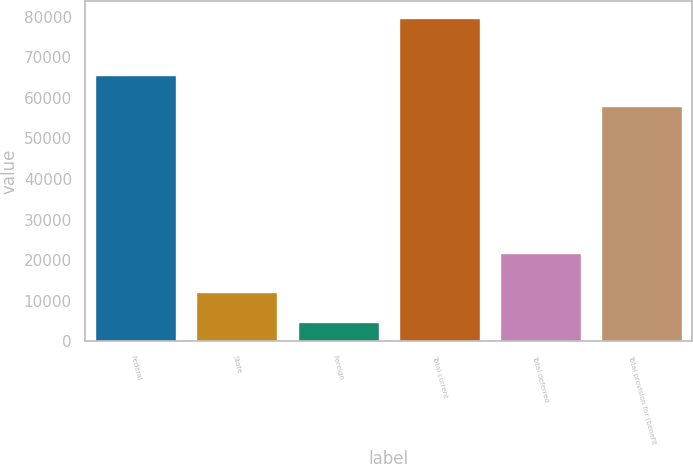<chart> <loc_0><loc_0><loc_500><loc_500><bar_chart><fcel>Federal<fcel>State<fcel>Foreign<fcel>Total current<fcel>Total deferred<fcel>Total provision for (benefit<nl><fcel>65548.3<fcel>12187.3<fcel>4675<fcel>79798<fcel>21762<fcel>58036<nl></chart> 